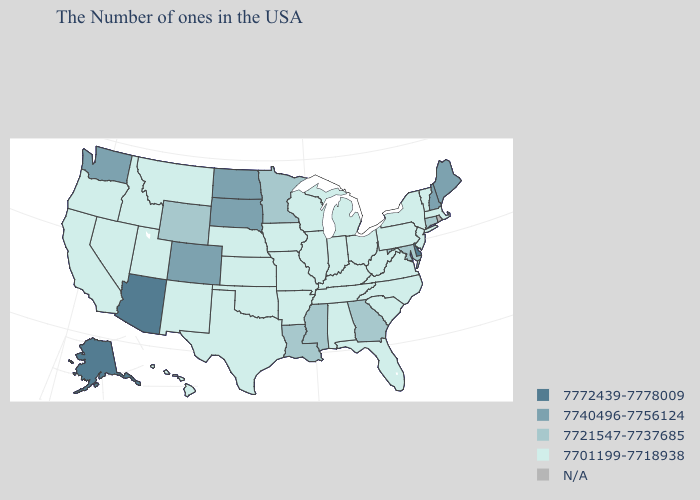Name the states that have a value in the range 7721547-7737685?
Write a very short answer. Connecticut, Maryland, Georgia, Mississippi, Louisiana, Minnesota, Wyoming. Does the first symbol in the legend represent the smallest category?
Quick response, please. No. Name the states that have a value in the range N/A?
Concise answer only. Rhode Island. Name the states that have a value in the range 7740496-7756124?
Be succinct. Maine, New Hampshire, South Dakota, North Dakota, Colorado, Washington. Does Montana have the lowest value in the West?
Short answer required. Yes. Which states hav the highest value in the MidWest?
Short answer required. South Dakota, North Dakota. Does Alaska have the highest value in the USA?
Short answer required. Yes. Among the states that border New York , which have the lowest value?
Short answer required. Massachusetts, Vermont, New Jersey, Pennsylvania. What is the value of Alabama?
Give a very brief answer. 7701199-7718938. Does Nebraska have the lowest value in the USA?
Write a very short answer. Yes. Does Connecticut have the lowest value in the Northeast?
Answer briefly. No. How many symbols are there in the legend?
Keep it brief. 5. What is the value of South Dakota?
Be succinct. 7740496-7756124. Does Colorado have the lowest value in the USA?
Short answer required. No. 